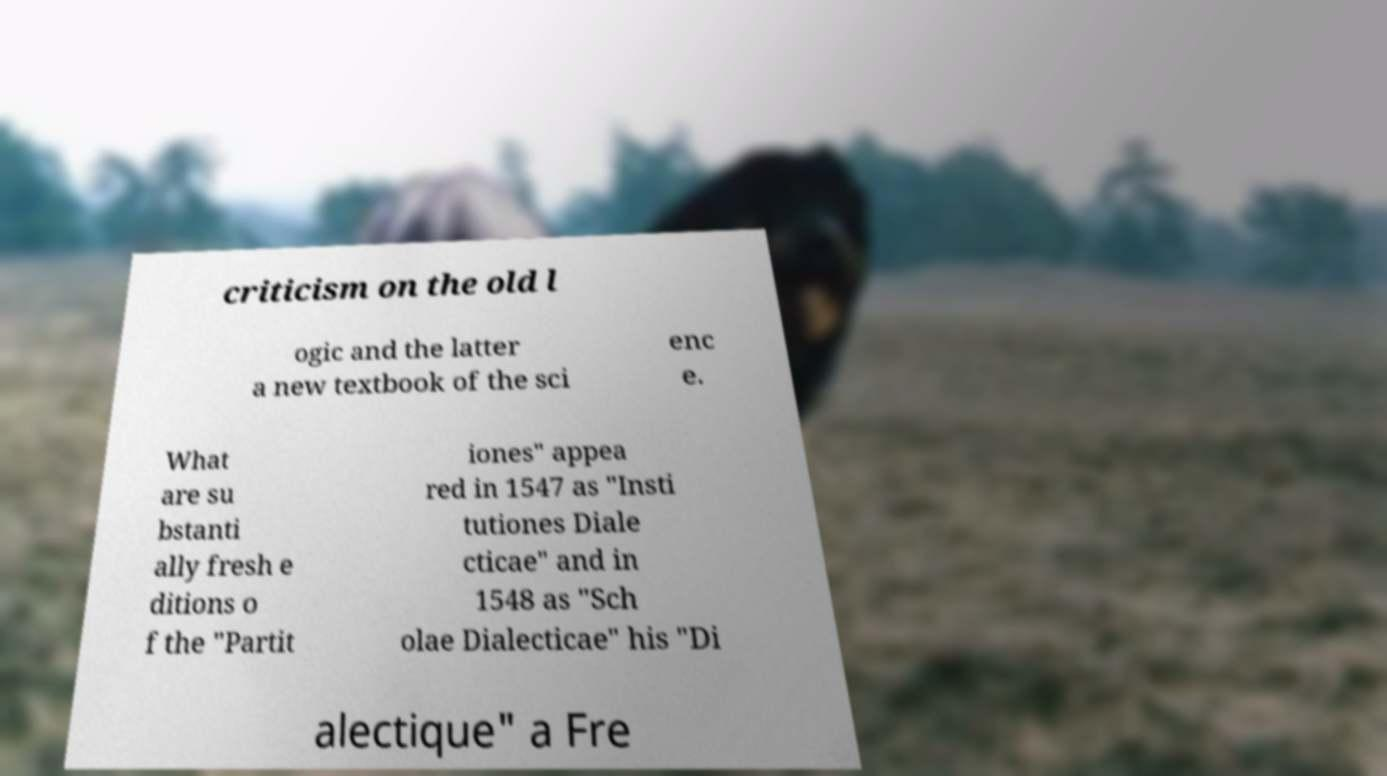I need the written content from this picture converted into text. Can you do that? criticism on the old l ogic and the latter a new textbook of the sci enc e. What are su bstanti ally fresh e ditions o f the "Partit iones" appea red in 1547 as "Insti tutiones Diale cticae" and in 1548 as "Sch olae Dialecticae" his "Di alectique" a Fre 